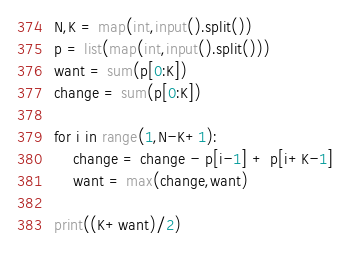Convert code to text. <code><loc_0><loc_0><loc_500><loc_500><_Python_>N,K = map(int,input().split())
p = list(map(int,input().split()))
want = sum(p[0:K])
change = sum(p[0:K])

for i in range(1,N-K+1):
    change = change - p[i-1] + p[i+K-1]
    want = max(change,want)

print((K+want)/2)</code> 